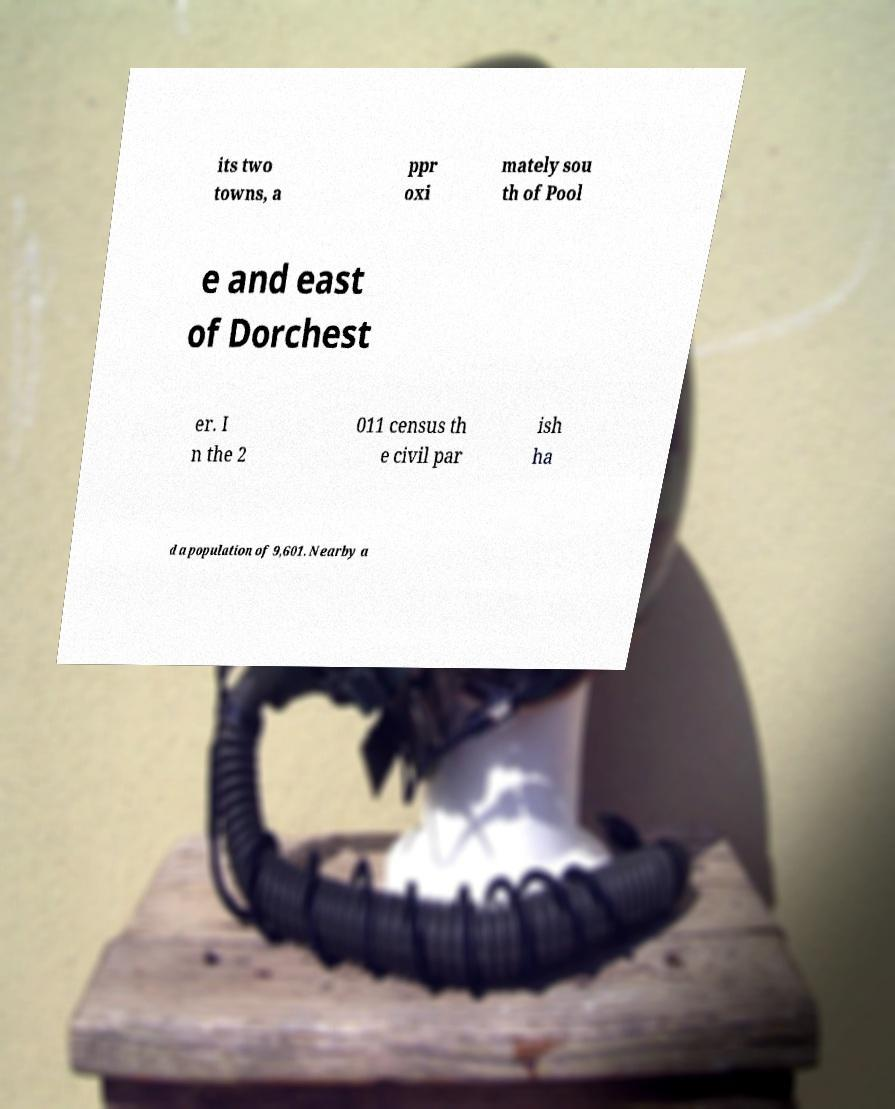For documentation purposes, I need the text within this image transcribed. Could you provide that? its two towns, a ppr oxi mately sou th of Pool e and east of Dorchest er. I n the 2 011 census th e civil par ish ha d a population of 9,601. Nearby a 